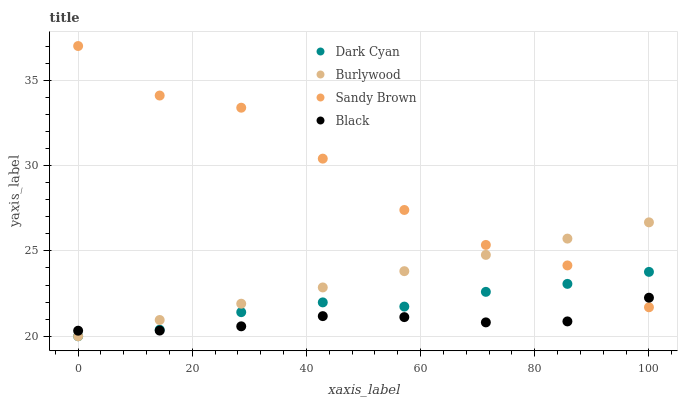Does Black have the minimum area under the curve?
Answer yes or no. Yes. Does Sandy Brown have the maximum area under the curve?
Answer yes or no. Yes. Does Burlywood have the minimum area under the curve?
Answer yes or no. No. Does Burlywood have the maximum area under the curve?
Answer yes or no. No. Is Burlywood the smoothest?
Answer yes or no. Yes. Is Sandy Brown the roughest?
Answer yes or no. Yes. Is Sandy Brown the smoothest?
Answer yes or no. No. Is Burlywood the roughest?
Answer yes or no. No. Does Dark Cyan have the lowest value?
Answer yes or no. Yes. Does Sandy Brown have the lowest value?
Answer yes or no. No. Does Sandy Brown have the highest value?
Answer yes or no. Yes. Does Burlywood have the highest value?
Answer yes or no. No. Does Burlywood intersect Black?
Answer yes or no. Yes. Is Burlywood less than Black?
Answer yes or no. No. Is Burlywood greater than Black?
Answer yes or no. No. 